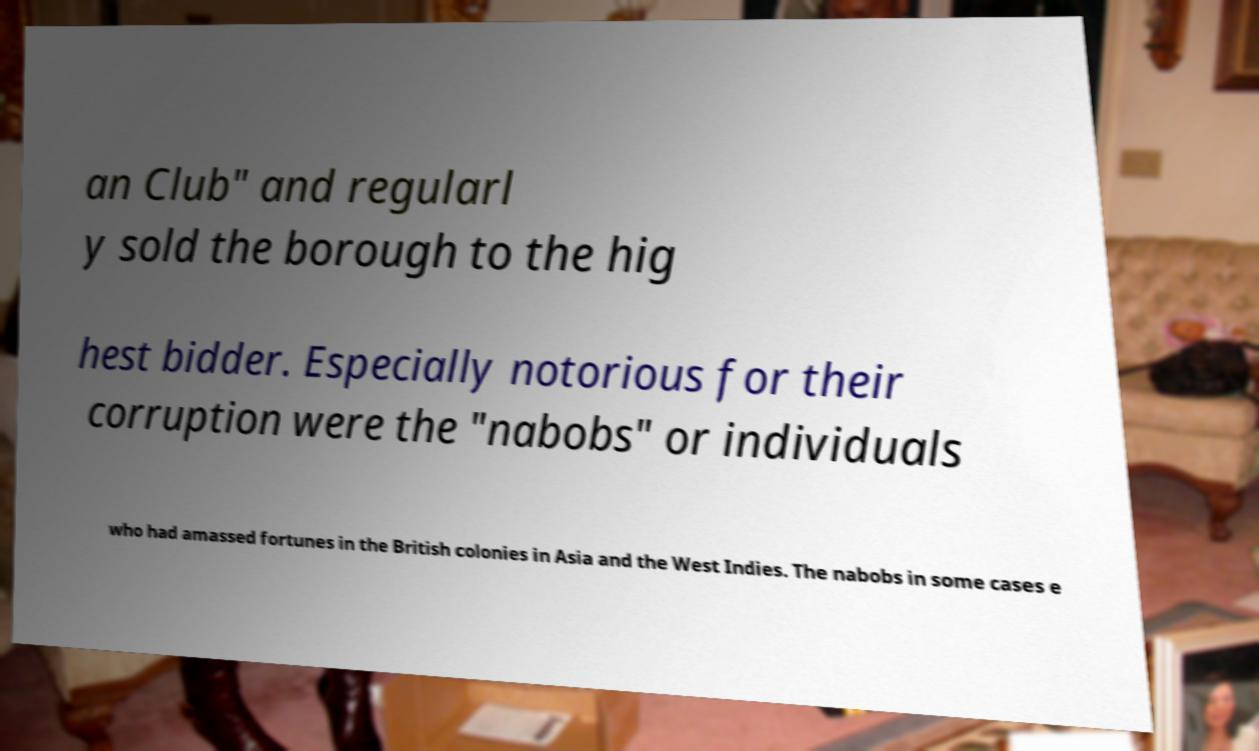Can you read and provide the text displayed in the image?This photo seems to have some interesting text. Can you extract and type it out for me? an Club" and regularl y sold the borough to the hig hest bidder. Especially notorious for their corruption were the "nabobs" or individuals who had amassed fortunes in the British colonies in Asia and the West Indies. The nabobs in some cases e 